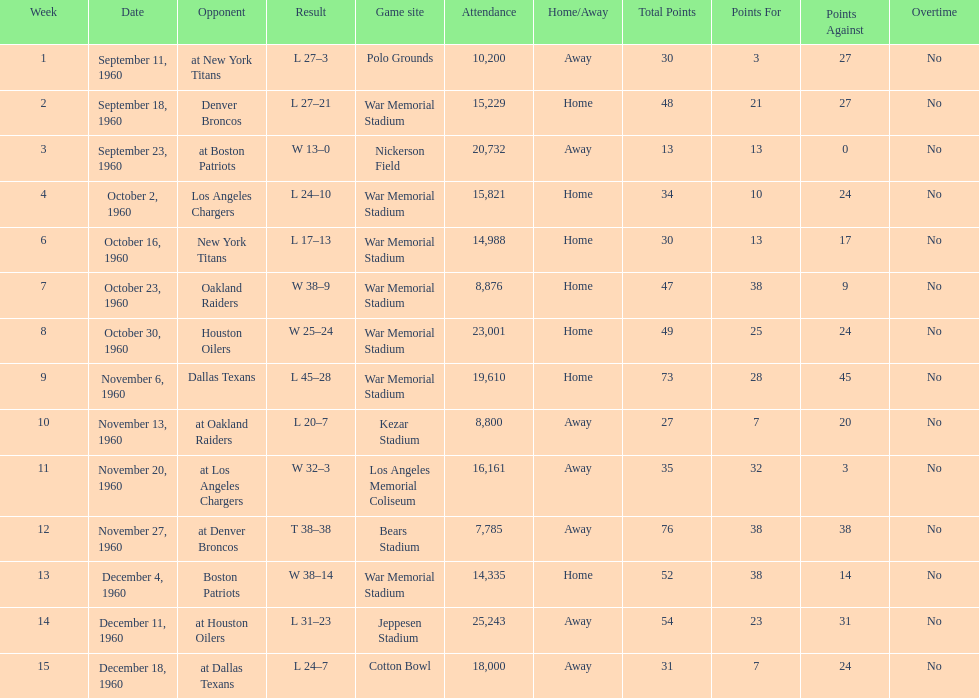How many times was war memorial stadium the game site? 6. 